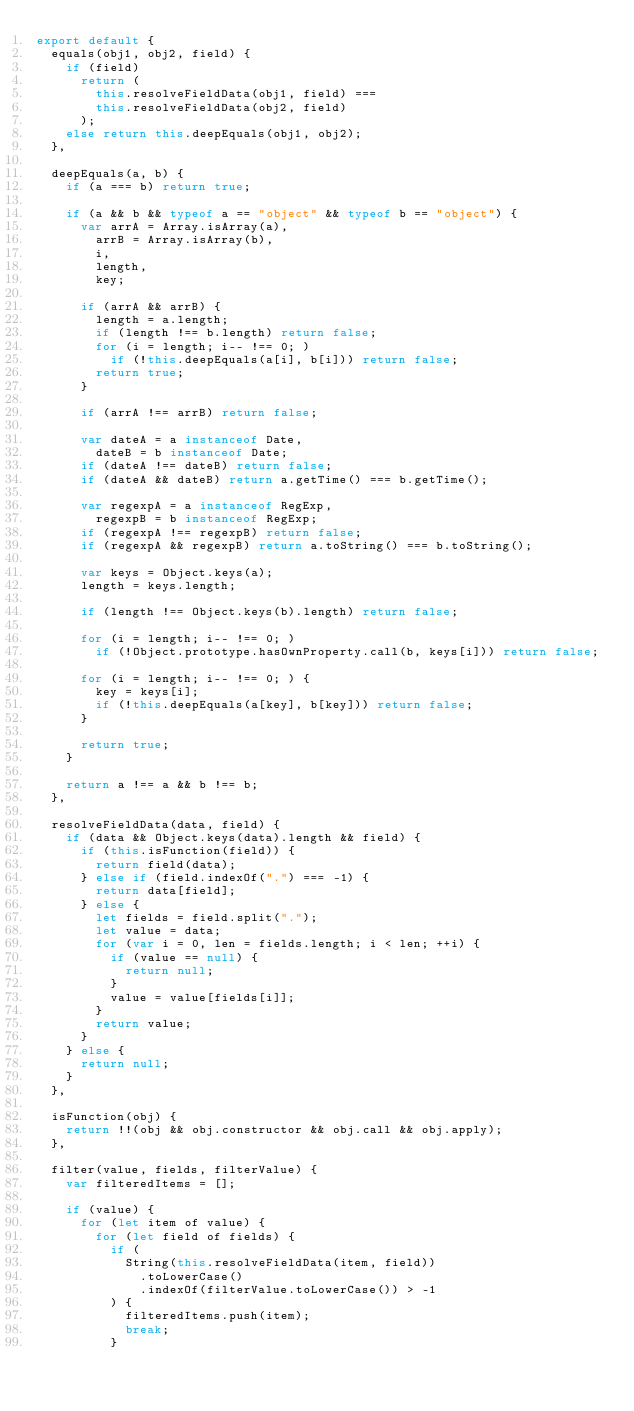<code> <loc_0><loc_0><loc_500><loc_500><_JavaScript_>export default {
  equals(obj1, obj2, field) {
    if (field)
      return (
        this.resolveFieldData(obj1, field) ===
        this.resolveFieldData(obj2, field)
      );
    else return this.deepEquals(obj1, obj2);
  },

  deepEquals(a, b) {
    if (a === b) return true;

    if (a && b && typeof a == "object" && typeof b == "object") {
      var arrA = Array.isArray(a),
        arrB = Array.isArray(b),
        i,
        length,
        key;

      if (arrA && arrB) {
        length = a.length;
        if (length !== b.length) return false;
        for (i = length; i-- !== 0; )
          if (!this.deepEquals(a[i], b[i])) return false;
        return true;
      }

      if (arrA !== arrB) return false;

      var dateA = a instanceof Date,
        dateB = b instanceof Date;
      if (dateA !== dateB) return false;
      if (dateA && dateB) return a.getTime() === b.getTime();

      var regexpA = a instanceof RegExp,
        regexpB = b instanceof RegExp;
      if (regexpA !== regexpB) return false;
      if (regexpA && regexpB) return a.toString() === b.toString();

      var keys = Object.keys(a);
      length = keys.length;

      if (length !== Object.keys(b).length) return false;

      for (i = length; i-- !== 0; )
        if (!Object.prototype.hasOwnProperty.call(b, keys[i])) return false;

      for (i = length; i-- !== 0; ) {
        key = keys[i];
        if (!this.deepEquals(a[key], b[key])) return false;
      }

      return true;
    }

    return a !== a && b !== b;
  },

  resolveFieldData(data, field) {
    if (data && Object.keys(data).length && field) {
      if (this.isFunction(field)) {
        return field(data);
      } else if (field.indexOf(".") === -1) {
        return data[field];
      } else {
        let fields = field.split(".");
        let value = data;
        for (var i = 0, len = fields.length; i < len; ++i) {
          if (value == null) {
            return null;
          }
          value = value[fields[i]];
        }
        return value;
      }
    } else {
      return null;
    }
  },

  isFunction(obj) {
    return !!(obj && obj.constructor && obj.call && obj.apply);
  },

  filter(value, fields, filterValue) {
    var filteredItems = [];

    if (value) {
      for (let item of value) {
        for (let field of fields) {
          if (
            String(this.resolveFieldData(item, field))
              .toLowerCase()
              .indexOf(filterValue.toLowerCase()) > -1
          ) {
            filteredItems.push(item);
            break;
          }</code> 